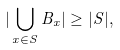<formula> <loc_0><loc_0><loc_500><loc_500>| \bigcup _ { x \in S } B _ { x } | \geq | S | ,</formula> 